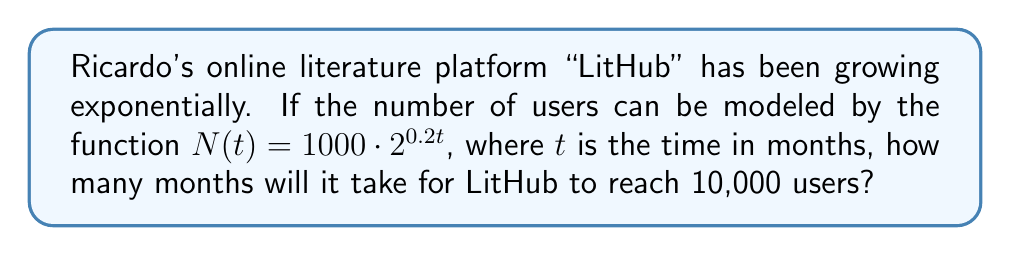Solve this math problem. Let's approach this step-by-step:

1) We need to solve the equation:
   $N(t) = 10000$

2) Substituting the given function:
   $1000 \cdot 2^{0.2t} = 10000$

3) Dividing both sides by 1000:
   $2^{0.2t} = 10$

4) Taking the logarithm (base 2) of both sides:
   $\log_2(2^{0.2t}) = \log_2(10)$

5) Simplifying the left side using the logarithm property $\log_a(a^x) = x$:
   $0.2t = \log_2(10)$

6) Dividing both sides by 0.2:
   $t = \frac{\log_2(10)}{0.2}$

7) We can change the base of the logarithm using the change of base formula:
   $t = \frac{\log(10)}{\log(2) \cdot 0.2}$

8) Calculating this value:
   $t \approx 16.61$ months

9) Since we can't have a fractional month in this context, we round up to the nearest whole month.
Answer: 17 months 